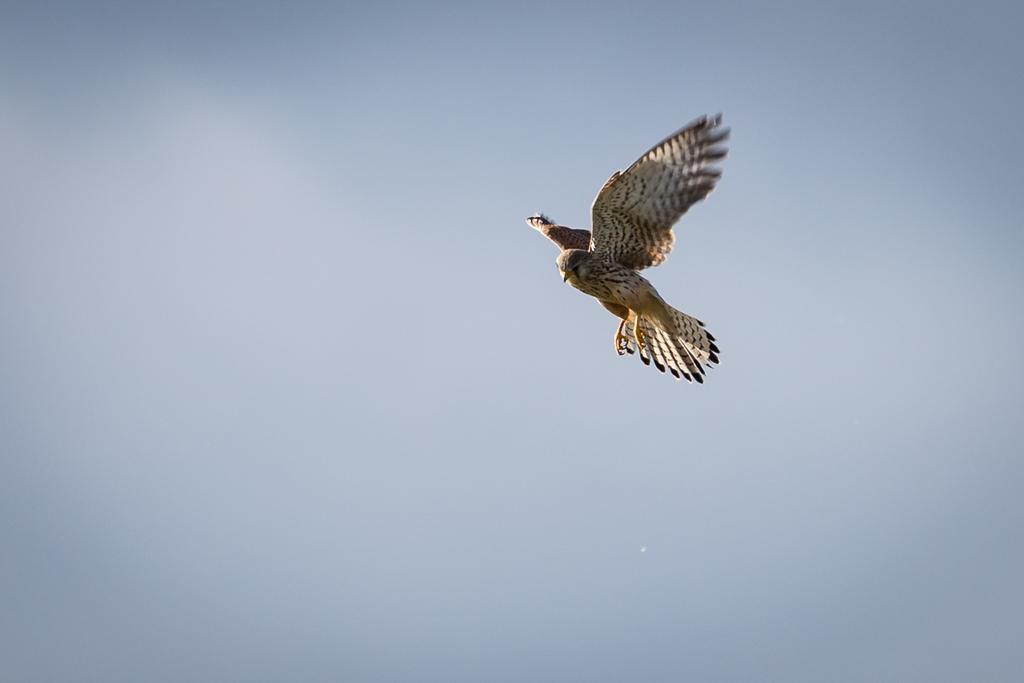How would you summarize this image in a sentence or two? This picture is clicked outside the city. On the right there is a bird flying in the sky. In the background we can see the sky. 